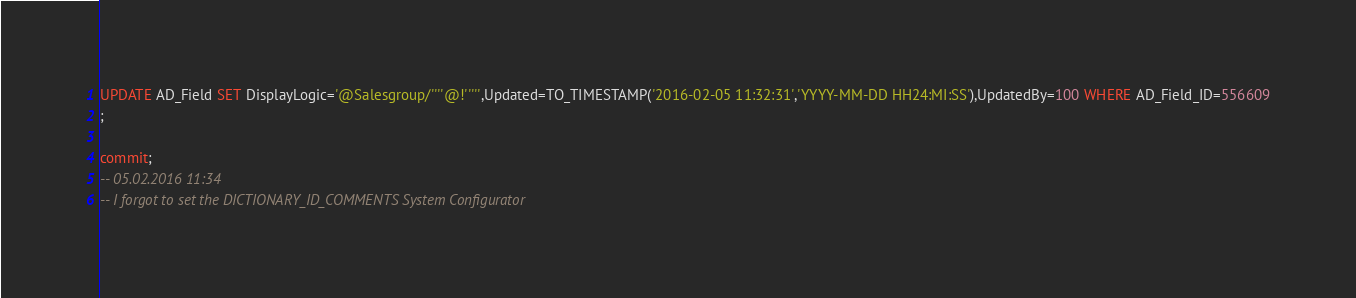<code> <loc_0><loc_0><loc_500><loc_500><_SQL_>UPDATE AD_Field SET DisplayLogic='@Salesgroup/''''@!''''',Updated=TO_TIMESTAMP('2016-02-05 11:32:31','YYYY-MM-DD HH24:MI:SS'),UpdatedBy=100 WHERE AD_Field_ID=556609
;

commit;
-- 05.02.2016 11:34
-- I forgot to set the DICTIONARY_ID_COMMENTS System Configurator</code> 